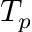<formula> <loc_0><loc_0><loc_500><loc_500>T _ { p }</formula> 